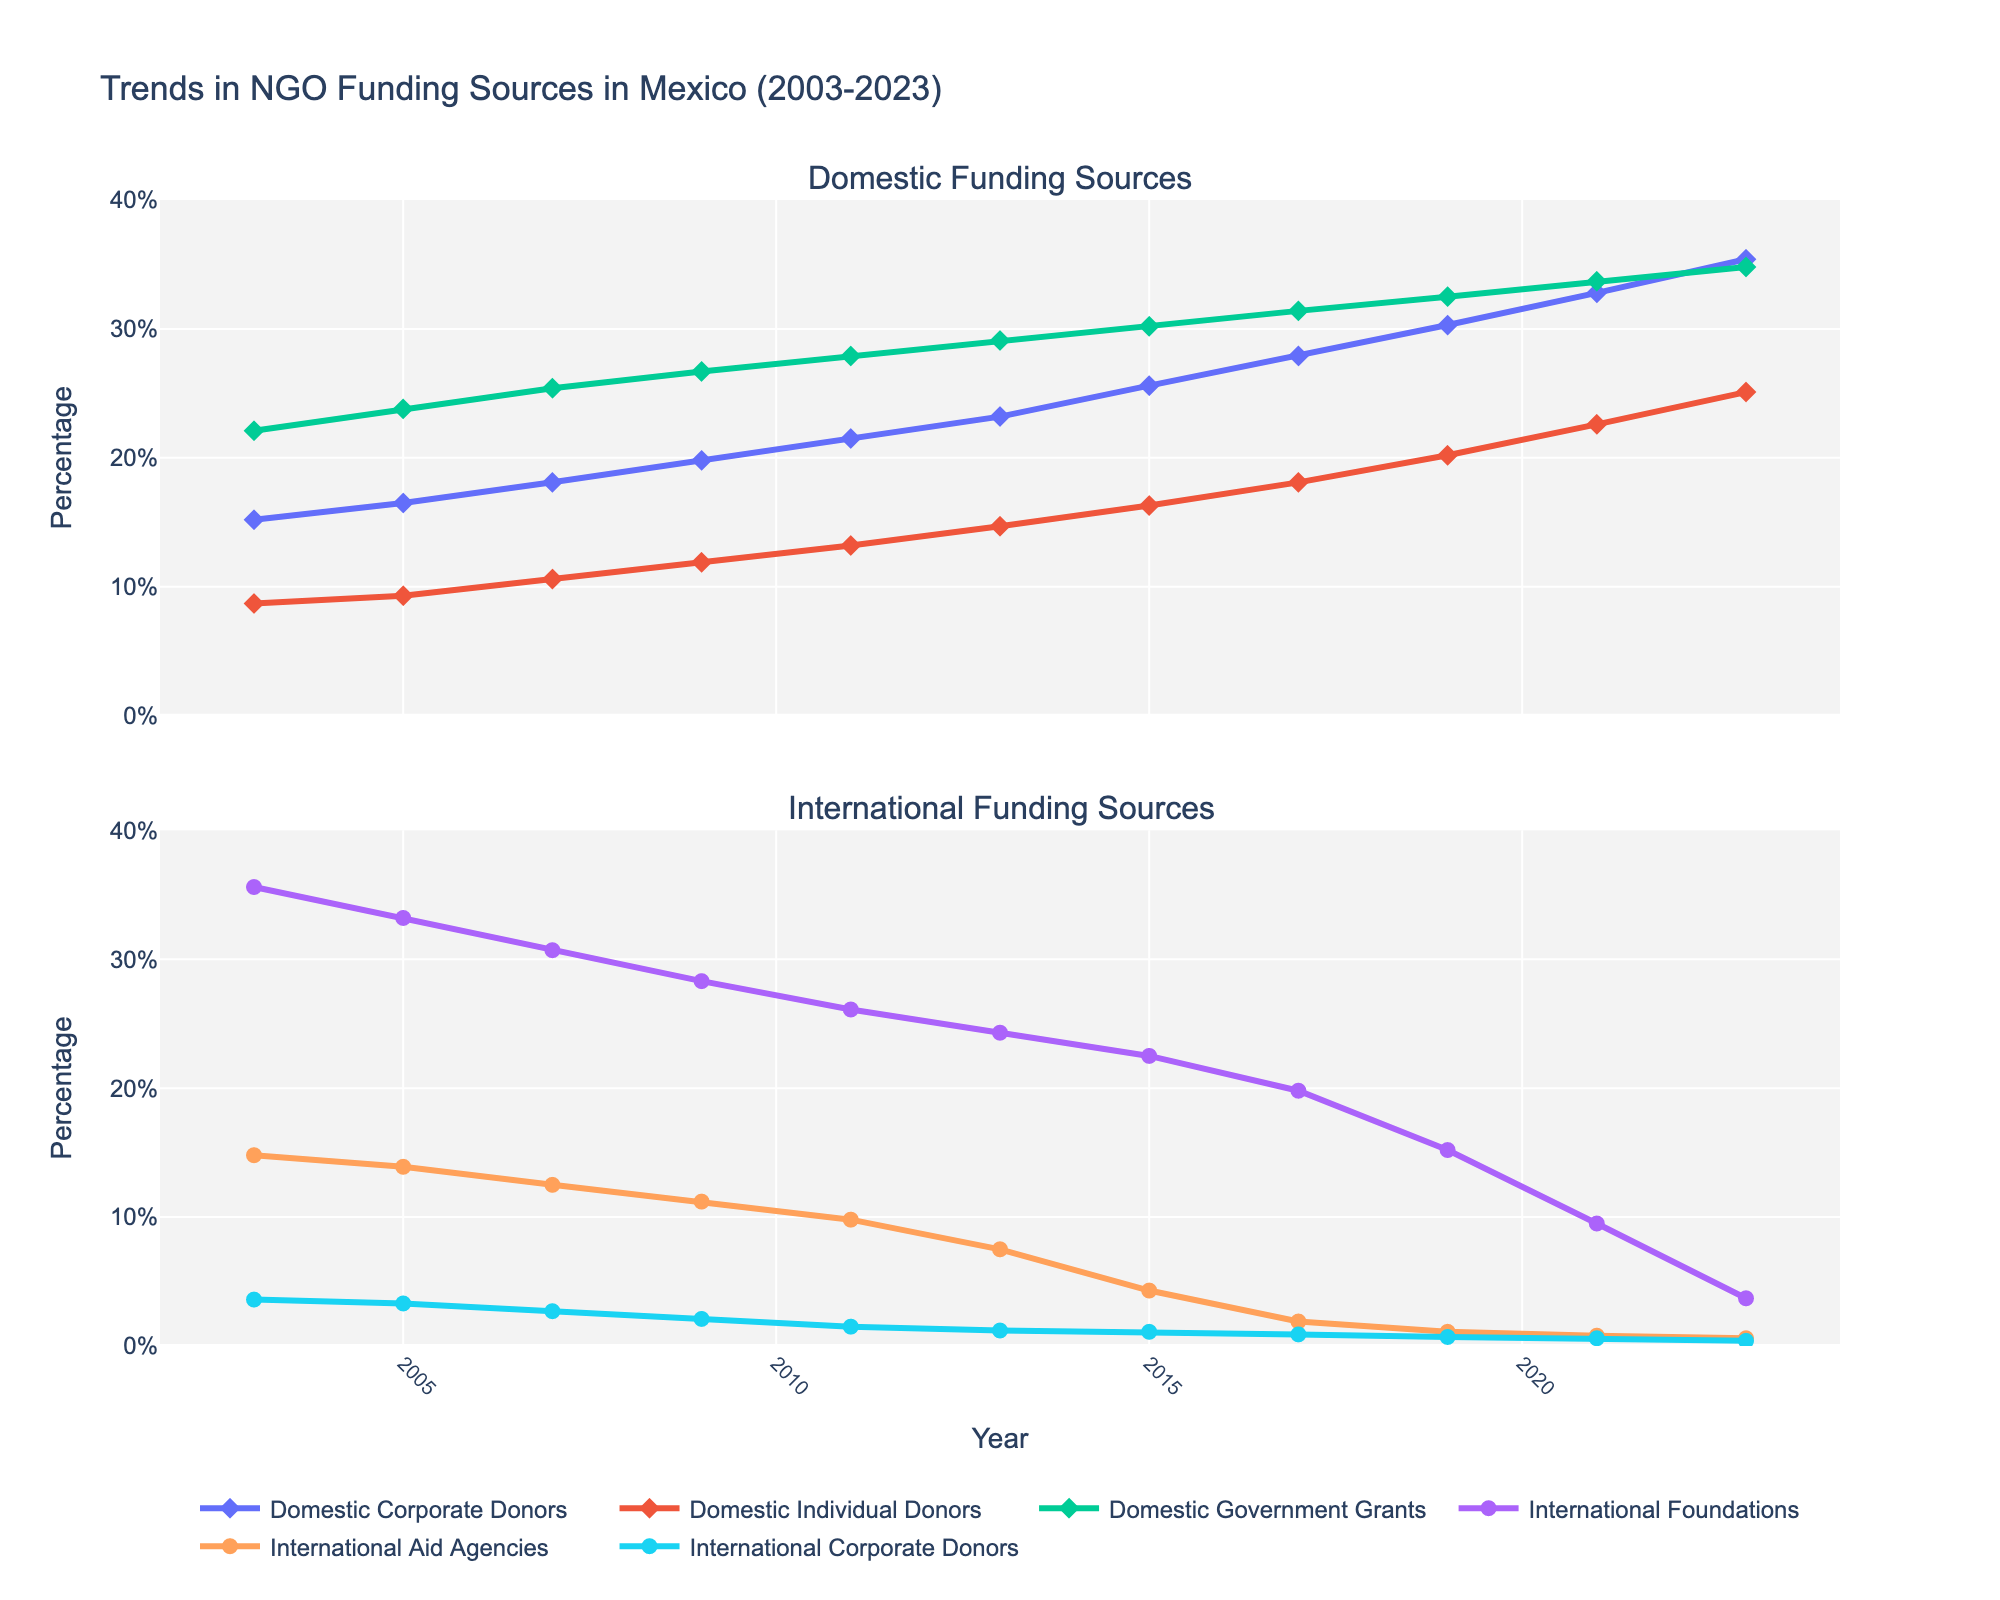Which year did Domestic Corporate Donors exceed 30%? Refer to the first subplot and look at the line with diamonds for Domestic Corporate Donors. The value exceeds 30% in the year 2019.
Answer: 2019 Compare the trends in International Foundations and Domestic Government Grants from 2003 to 2023. Which decreases the most and which increases the most? Look at the second subplot for International Foundations and the first subplot for Domestic Government Grants. International Foundations decrease significantly from 35.6% to 3.7%, while Domestic Government Grants increase from 22.1% to 34.8%.
Answer: International Foundations decreased the most, Domestic Government Grants increased the most What was the difference between Domestic Individual Donors in 2003 and 2023? In the first subplot, find the value for Domestic Individual Donors in 2003 (8.7%) and in 2023 (25.1%). Subtract the former from the latter: 25.1% - 8.7% = 16.4%.
Answer: 16.4% Which category had the steepest decline among International funding sources after 2017? Refer to the second subplot, identify the lines from 2017 to 2023. International Foundations show the steepest decline from 19.8% to 3.7%.
Answer: International Foundations Summing the values for Domestic Donors in 2023, what is the total percentage? Add the percentages for Domestic Corporate Donors (35.4%), Domestic Individual Donors (25.1%), and Domestic Government Grants (34.8%) from the first subplot. Total = 35.4% + 25.1% + 34.8% = 95.3%.
Answer: 95.3% 